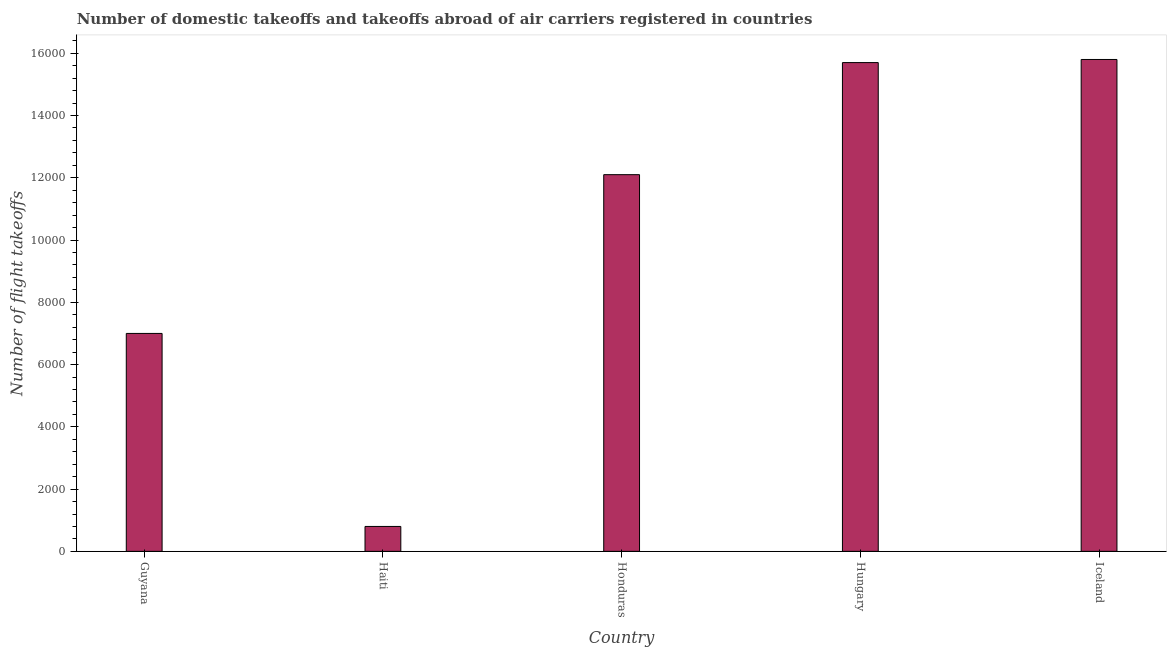Does the graph contain any zero values?
Your answer should be compact. No. Does the graph contain grids?
Your answer should be very brief. No. What is the title of the graph?
Provide a short and direct response. Number of domestic takeoffs and takeoffs abroad of air carriers registered in countries. What is the label or title of the X-axis?
Ensure brevity in your answer.  Country. What is the label or title of the Y-axis?
Provide a short and direct response. Number of flight takeoffs. What is the number of flight takeoffs in Haiti?
Keep it short and to the point. 800. Across all countries, what is the maximum number of flight takeoffs?
Provide a short and direct response. 1.58e+04. Across all countries, what is the minimum number of flight takeoffs?
Provide a succinct answer. 800. In which country was the number of flight takeoffs maximum?
Offer a very short reply. Iceland. In which country was the number of flight takeoffs minimum?
Provide a short and direct response. Haiti. What is the sum of the number of flight takeoffs?
Offer a terse response. 5.14e+04. What is the difference between the number of flight takeoffs in Hungary and Iceland?
Make the answer very short. -100. What is the average number of flight takeoffs per country?
Offer a very short reply. 1.03e+04. What is the median number of flight takeoffs?
Your answer should be compact. 1.21e+04. In how many countries, is the number of flight takeoffs greater than 14400 ?
Ensure brevity in your answer.  2. What is the ratio of the number of flight takeoffs in Haiti to that in Hungary?
Provide a succinct answer. 0.05. Is the number of flight takeoffs in Honduras less than that in Iceland?
Keep it short and to the point. Yes. What is the difference between the highest and the lowest number of flight takeoffs?
Keep it short and to the point. 1.50e+04. In how many countries, is the number of flight takeoffs greater than the average number of flight takeoffs taken over all countries?
Your answer should be very brief. 3. Are all the bars in the graph horizontal?
Offer a very short reply. No. How many countries are there in the graph?
Provide a short and direct response. 5. Are the values on the major ticks of Y-axis written in scientific E-notation?
Offer a very short reply. No. What is the Number of flight takeoffs in Guyana?
Your answer should be compact. 7000. What is the Number of flight takeoffs in Haiti?
Ensure brevity in your answer.  800. What is the Number of flight takeoffs of Honduras?
Provide a short and direct response. 1.21e+04. What is the Number of flight takeoffs of Hungary?
Provide a succinct answer. 1.57e+04. What is the Number of flight takeoffs in Iceland?
Make the answer very short. 1.58e+04. What is the difference between the Number of flight takeoffs in Guyana and Haiti?
Ensure brevity in your answer.  6200. What is the difference between the Number of flight takeoffs in Guyana and Honduras?
Offer a terse response. -5100. What is the difference between the Number of flight takeoffs in Guyana and Hungary?
Keep it short and to the point. -8700. What is the difference between the Number of flight takeoffs in Guyana and Iceland?
Provide a short and direct response. -8800. What is the difference between the Number of flight takeoffs in Haiti and Honduras?
Offer a terse response. -1.13e+04. What is the difference between the Number of flight takeoffs in Haiti and Hungary?
Keep it short and to the point. -1.49e+04. What is the difference between the Number of flight takeoffs in Haiti and Iceland?
Offer a very short reply. -1.50e+04. What is the difference between the Number of flight takeoffs in Honduras and Hungary?
Keep it short and to the point. -3600. What is the difference between the Number of flight takeoffs in Honduras and Iceland?
Give a very brief answer. -3700. What is the difference between the Number of flight takeoffs in Hungary and Iceland?
Offer a very short reply. -100. What is the ratio of the Number of flight takeoffs in Guyana to that in Haiti?
Keep it short and to the point. 8.75. What is the ratio of the Number of flight takeoffs in Guyana to that in Honduras?
Offer a very short reply. 0.58. What is the ratio of the Number of flight takeoffs in Guyana to that in Hungary?
Your answer should be compact. 0.45. What is the ratio of the Number of flight takeoffs in Guyana to that in Iceland?
Offer a very short reply. 0.44. What is the ratio of the Number of flight takeoffs in Haiti to that in Honduras?
Provide a succinct answer. 0.07. What is the ratio of the Number of flight takeoffs in Haiti to that in Hungary?
Keep it short and to the point. 0.05. What is the ratio of the Number of flight takeoffs in Haiti to that in Iceland?
Keep it short and to the point. 0.05. What is the ratio of the Number of flight takeoffs in Honduras to that in Hungary?
Give a very brief answer. 0.77. What is the ratio of the Number of flight takeoffs in Honduras to that in Iceland?
Ensure brevity in your answer.  0.77. What is the ratio of the Number of flight takeoffs in Hungary to that in Iceland?
Offer a very short reply. 0.99. 